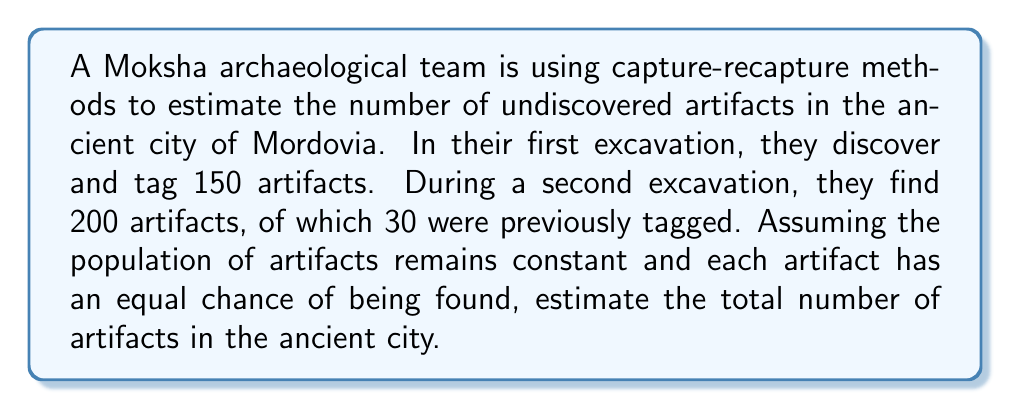Help me with this question. Let's approach this step-by-step using the Lincoln-Petersen method:

1) Let $N$ be the total number of artifacts in the population.
2) Let $M$ be the number of artifacts tagged in the first excavation (150).
3) Let $C$ be the total number of artifacts caught in the second excavation (200).
4) Let $R$ be the number of recaptured (tagged) artifacts in the second excavation (30).

The Lincoln-Petersen formula is:

$$N = \frac{MC}{R}$$

This formula assumes that the ratio of marked to unmarked artifacts in the second sample is representative of the entire population.

Substituting our values:

$$N = \frac{150 \times 200}{30}$$

Simplifying:

$$N = \frac{30,000}{30} = 1,000$$

Therefore, we estimate that there are approximately 1,000 artifacts in the ancient city of Mordovia.

Note: This method assumes a closed population, equal catchability, and that tags are not lost. In real archaeological scenarios, these assumptions may not always hold, and more complex models might be needed for accurate estimates.
Answer: 1,000 artifacts 